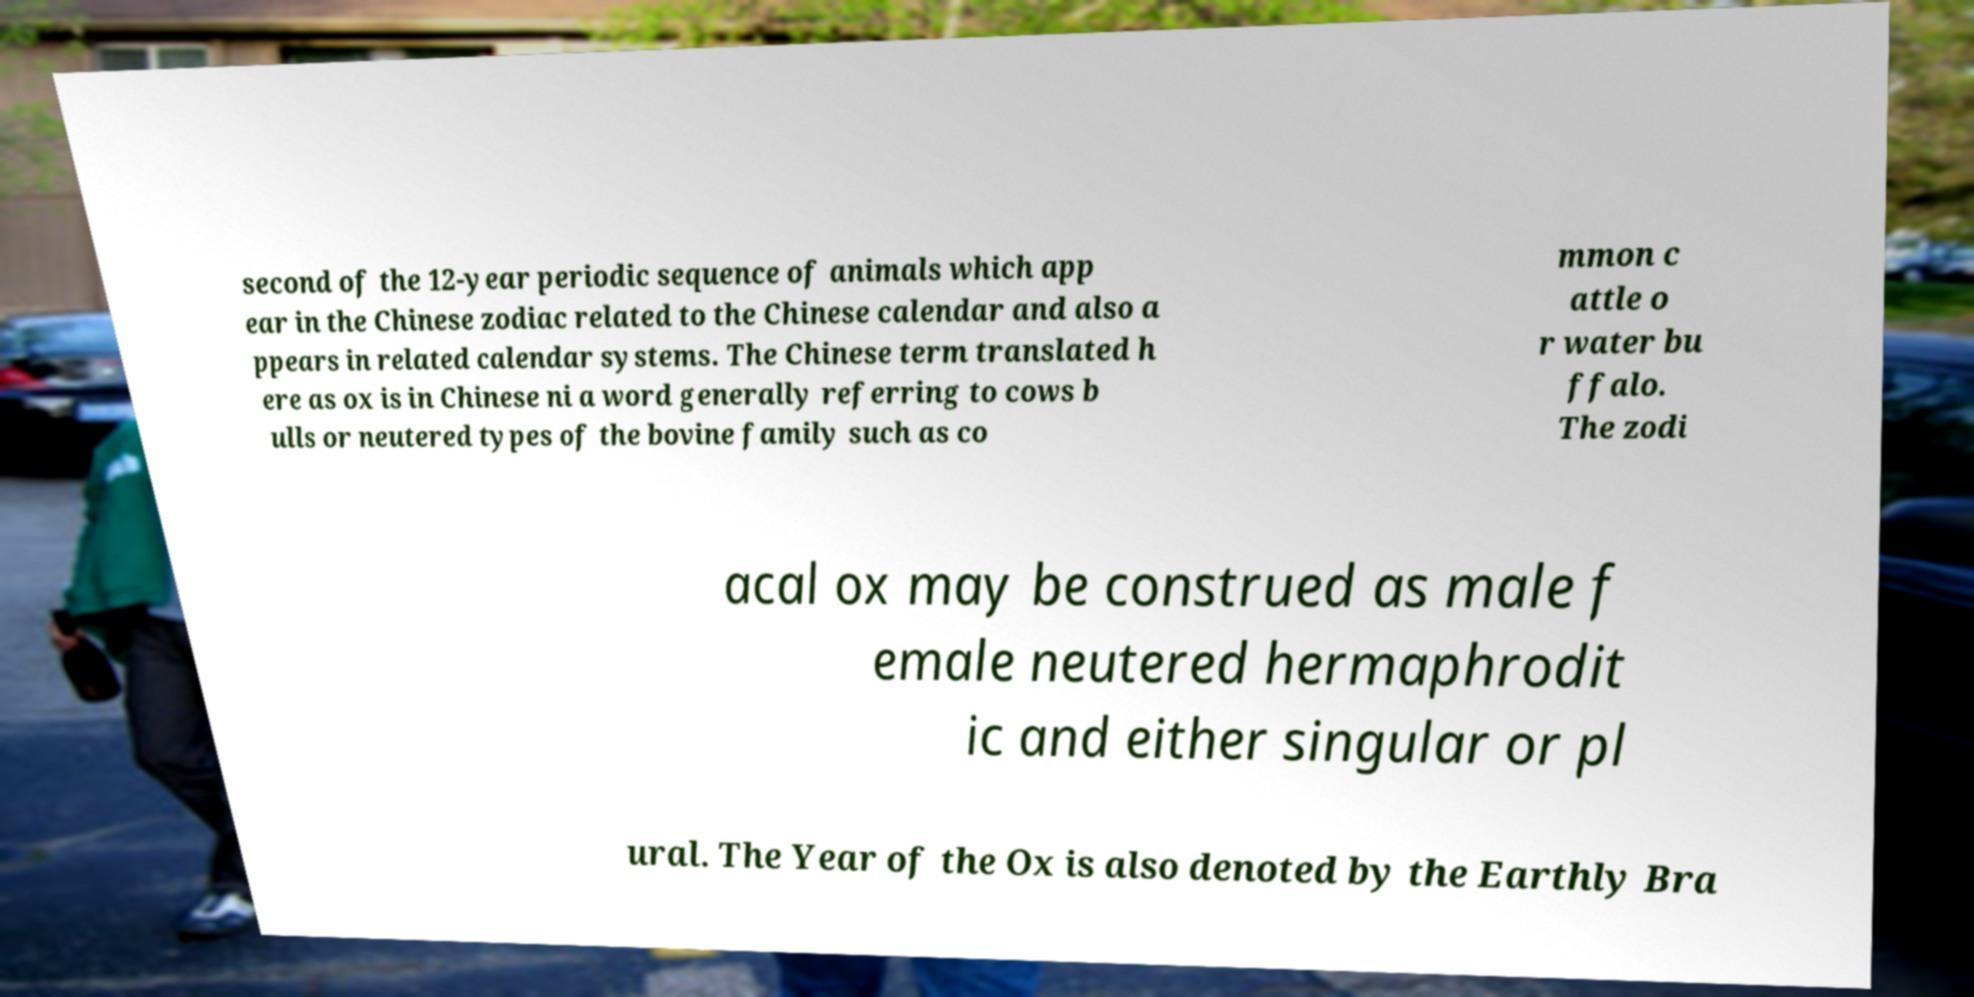Could you assist in decoding the text presented in this image and type it out clearly? second of the 12-year periodic sequence of animals which app ear in the Chinese zodiac related to the Chinese calendar and also a ppears in related calendar systems. The Chinese term translated h ere as ox is in Chinese ni a word generally referring to cows b ulls or neutered types of the bovine family such as co mmon c attle o r water bu ffalo. The zodi acal ox may be construed as male f emale neutered hermaphrodit ic and either singular or pl ural. The Year of the Ox is also denoted by the Earthly Bra 